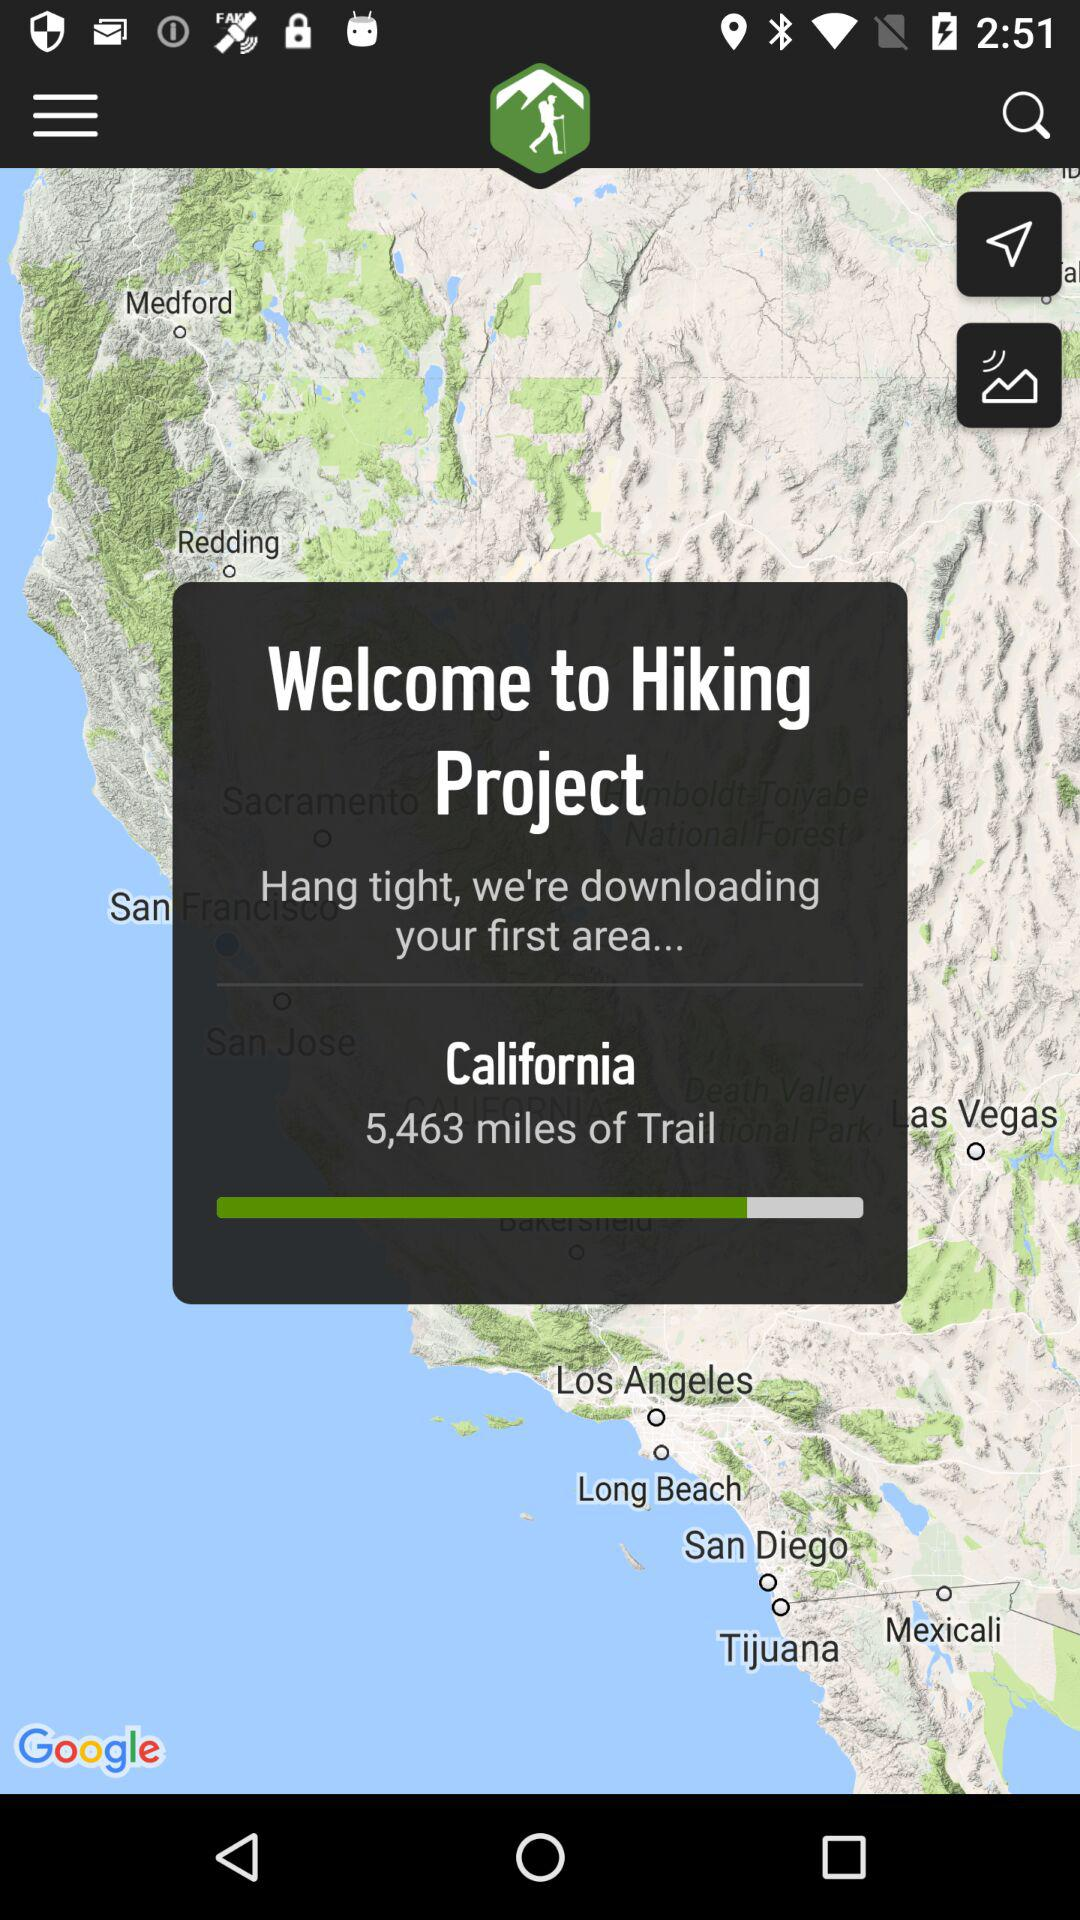How many miles of trail are there in California? There are 5,463 miles of trail in California. 